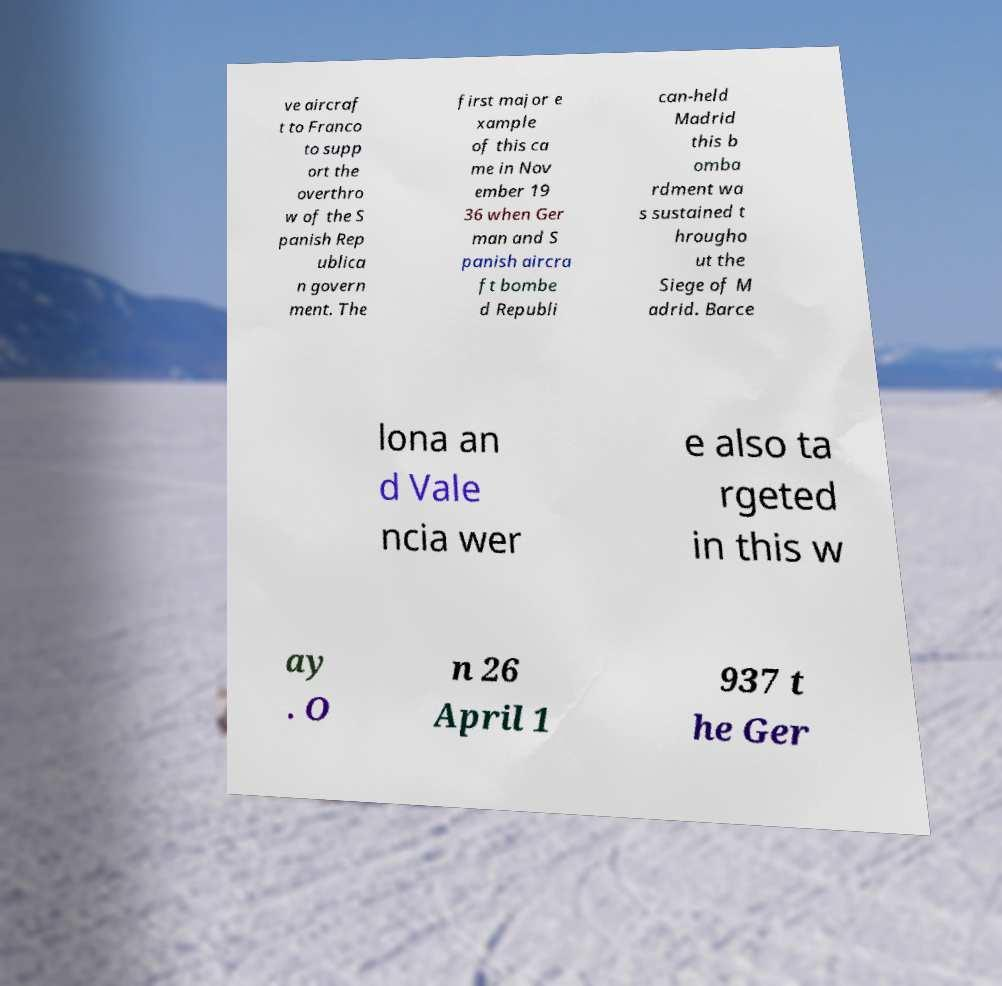Please identify and transcribe the text found in this image. ve aircraf t to Franco to supp ort the overthro w of the S panish Rep ublica n govern ment. The first major e xample of this ca me in Nov ember 19 36 when Ger man and S panish aircra ft bombe d Republi can-held Madrid this b omba rdment wa s sustained t hrougho ut the Siege of M adrid. Barce lona an d Vale ncia wer e also ta rgeted in this w ay . O n 26 April 1 937 t he Ger 